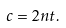Convert formula to latex. <formula><loc_0><loc_0><loc_500><loc_500>c = 2 n t .</formula> 